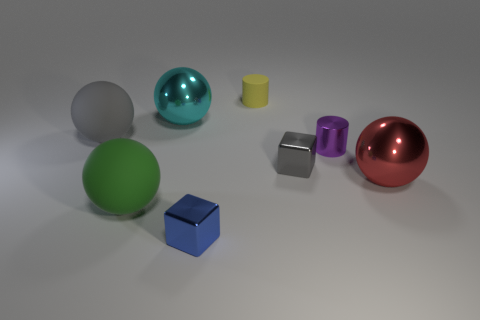What number of cyan things are either rubber objects or matte blocks?
Provide a short and direct response. 0. What number of blue things are the same shape as the small purple object?
Your answer should be very brief. 0. How many gray matte things have the same size as the green rubber thing?
Keep it short and to the point. 1. There is a red thing that is the same shape as the big cyan shiny thing; what is its material?
Give a very brief answer. Metal. There is a small shiny object that is in front of the large green rubber object; what color is it?
Offer a very short reply. Blue. Is the number of big gray things that are to the left of the purple cylinder greater than the number of small brown balls?
Provide a succinct answer. Yes. What is the color of the shiny cylinder?
Offer a terse response. Purple. There is a rubber thing that is on the right side of the large shiny ball that is behind the gray object right of the green rubber sphere; what is its shape?
Your answer should be compact. Cylinder. There is a sphere that is both behind the large red metallic thing and on the right side of the big gray ball; what is it made of?
Your response must be concise. Metal. There is a big metal object that is in front of the big matte object on the left side of the large green matte ball; what shape is it?
Ensure brevity in your answer.  Sphere. 